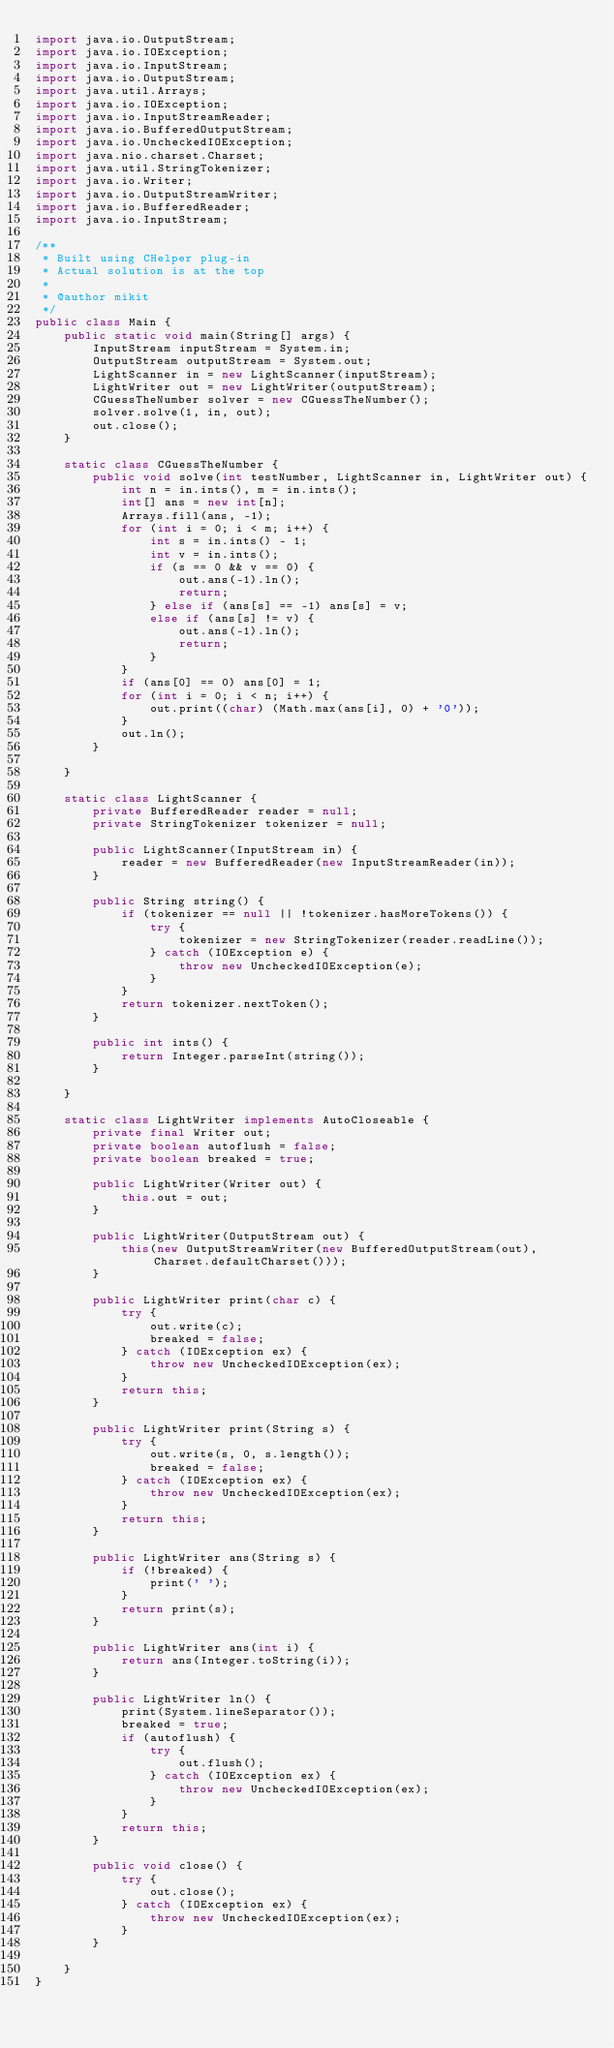<code> <loc_0><loc_0><loc_500><loc_500><_Java_>import java.io.OutputStream;
import java.io.IOException;
import java.io.InputStream;
import java.io.OutputStream;
import java.util.Arrays;
import java.io.IOException;
import java.io.InputStreamReader;
import java.io.BufferedOutputStream;
import java.io.UncheckedIOException;
import java.nio.charset.Charset;
import java.util.StringTokenizer;
import java.io.Writer;
import java.io.OutputStreamWriter;
import java.io.BufferedReader;
import java.io.InputStream;

/**
 * Built using CHelper plug-in
 * Actual solution is at the top
 *
 * @author mikit
 */
public class Main {
    public static void main(String[] args) {
        InputStream inputStream = System.in;
        OutputStream outputStream = System.out;
        LightScanner in = new LightScanner(inputStream);
        LightWriter out = new LightWriter(outputStream);
        CGuessTheNumber solver = new CGuessTheNumber();
        solver.solve(1, in, out);
        out.close();
    }

    static class CGuessTheNumber {
        public void solve(int testNumber, LightScanner in, LightWriter out) {
            int n = in.ints(), m = in.ints();
            int[] ans = new int[n];
            Arrays.fill(ans, -1);
            for (int i = 0; i < m; i++) {
                int s = in.ints() - 1;
                int v = in.ints();
                if (s == 0 && v == 0) {
                    out.ans(-1).ln();
                    return;
                } else if (ans[s] == -1) ans[s] = v;
                else if (ans[s] != v) {
                    out.ans(-1).ln();
                    return;
                }
            }
            if (ans[0] == 0) ans[0] = 1;
            for (int i = 0; i < n; i++) {
                out.print((char) (Math.max(ans[i], 0) + '0'));
            }
            out.ln();
        }

    }

    static class LightScanner {
        private BufferedReader reader = null;
        private StringTokenizer tokenizer = null;

        public LightScanner(InputStream in) {
            reader = new BufferedReader(new InputStreamReader(in));
        }

        public String string() {
            if (tokenizer == null || !tokenizer.hasMoreTokens()) {
                try {
                    tokenizer = new StringTokenizer(reader.readLine());
                } catch (IOException e) {
                    throw new UncheckedIOException(e);
                }
            }
            return tokenizer.nextToken();
        }

        public int ints() {
            return Integer.parseInt(string());
        }

    }

    static class LightWriter implements AutoCloseable {
        private final Writer out;
        private boolean autoflush = false;
        private boolean breaked = true;

        public LightWriter(Writer out) {
            this.out = out;
        }

        public LightWriter(OutputStream out) {
            this(new OutputStreamWriter(new BufferedOutputStream(out), Charset.defaultCharset()));
        }

        public LightWriter print(char c) {
            try {
                out.write(c);
                breaked = false;
            } catch (IOException ex) {
                throw new UncheckedIOException(ex);
            }
            return this;
        }

        public LightWriter print(String s) {
            try {
                out.write(s, 0, s.length());
                breaked = false;
            } catch (IOException ex) {
                throw new UncheckedIOException(ex);
            }
            return this;
        }

        public LightWriter ans(String s) {
            if (!breaked) {
                print(' ');
            }
            return print(s);
        }

        public LightWriter ans(int i) {
            return ans(Integer.toString(i));
        }

        public LightWriter ln() {
            print(System.lineSeparator());
            breaked = true;
            if (autoflush) {
                try {
                    out.flush();
                } catch (IOException ex) {
                    throw new UncheckedIOException(ex);
                }
            }
            return this;
        }

        public void close() {
            try {
                out.close();
            } catch (IOException ex) {
                throw new UncheckedIOException(ex);
            }
        }

    }
}

</code> 